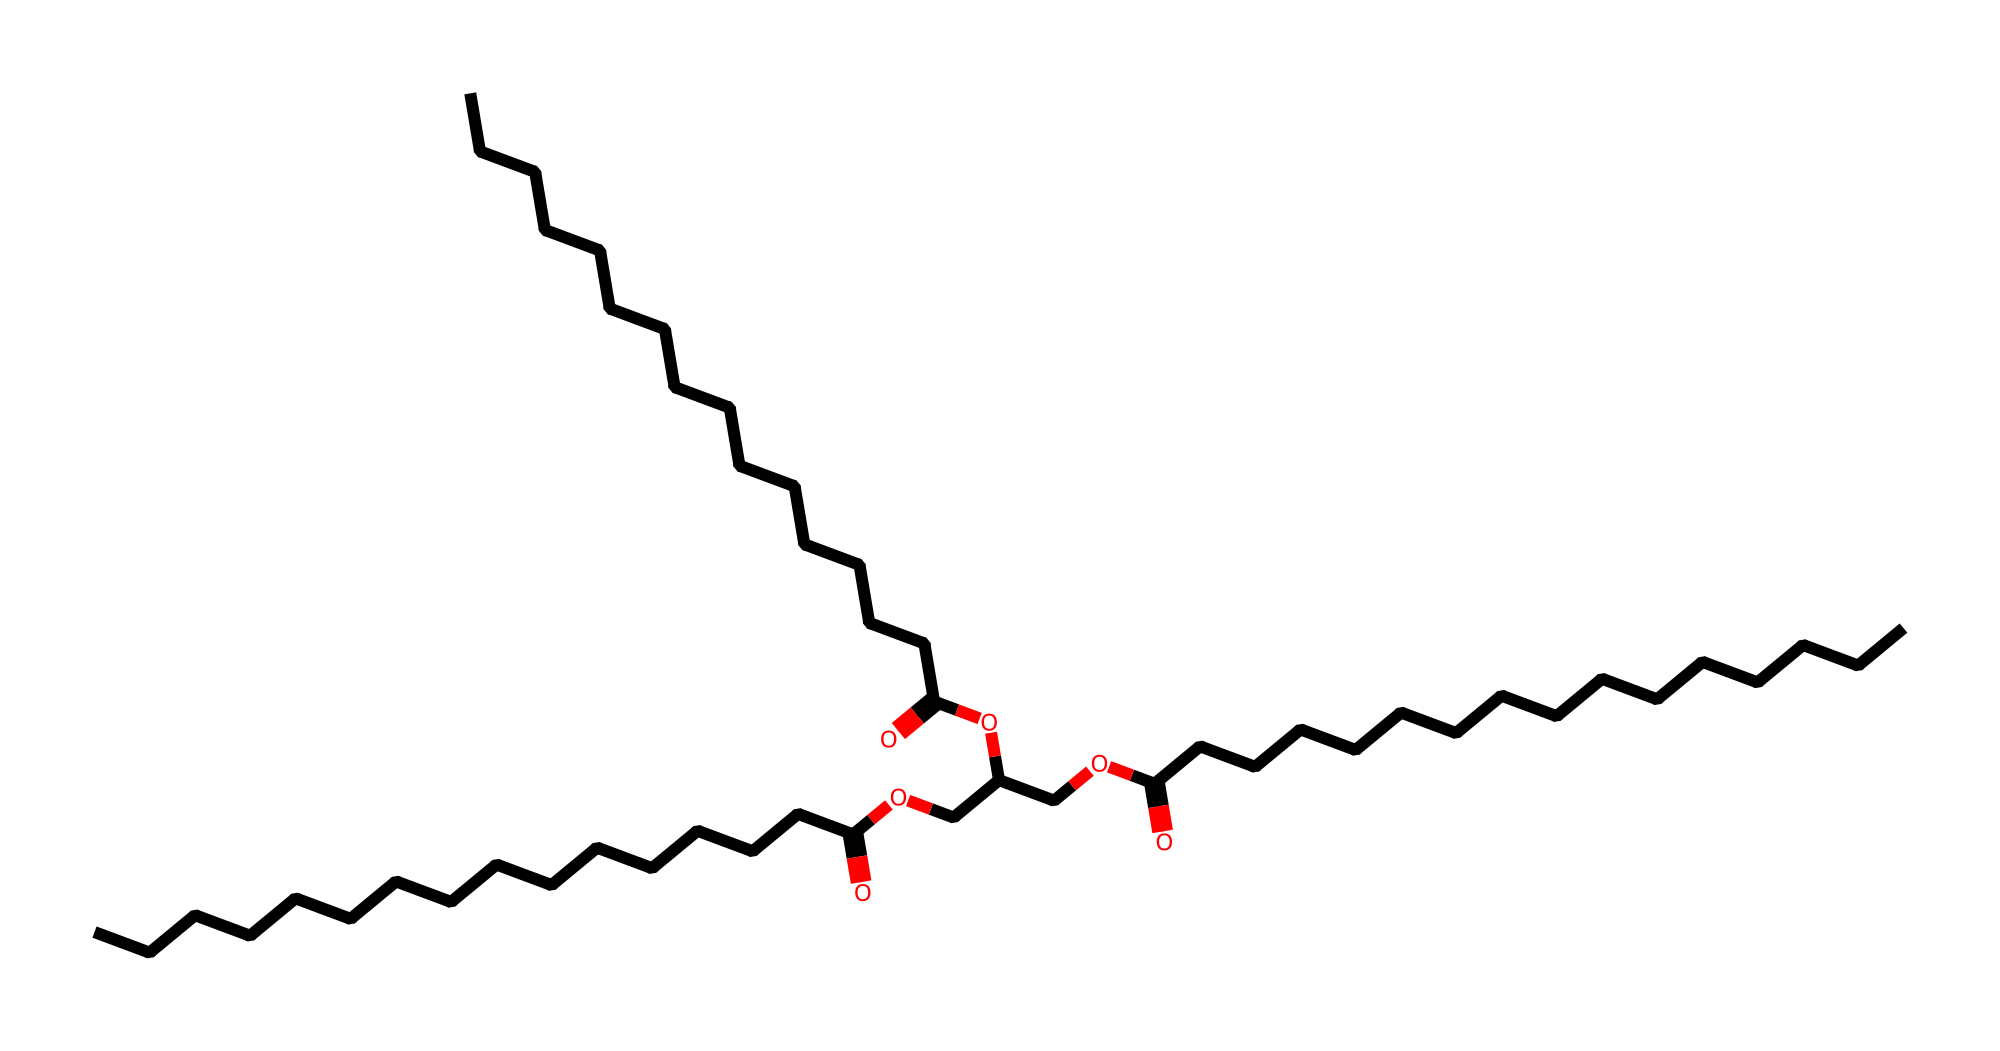How many carbon atoms are in this triglyceride? To find the number of carbon atoms, count the carbon symbols (C) in the SMILES representation. Each "C" represents one carbon atom. The structure reveals a total of 51 carbon atoms.
Answer: 51 What is the role of the ester functional groups in this molecule? Ester functional groups are formed through the reaction between alcohols and carboxylic acids, allowing triglycerides to store energy efficiently. The presence of these groups indicates that this molecule can serve as an energy-dense nutrient.
Answer: energy storage How many double bonds are present in this triglyceride? Examine the SMILES representation for any portions that indicate double bonds, which would be symbolized as "=". In this chemical, there are no double bonds present, indicating it is a saturated triglyceride.
Answer: 0 What type of lipid is indicated by this structure? The presence of a glycerol backbone attached to three fatty acid chains categorizes this chemical as a triglyceride. This type of lipid is primarily used for energy storage in organisms.
Answer: triglyceride Why is this triglyceride considered energy-dense? The large number of carbon and hydrogen atoms in the fatty acid chains provides extensive energy when metabolized. The structure showcases long hydrocarbon chains that can yield high amounts of energy during breakdown.
Answer: extensive energy How does this triglyceride contribute to endurance training? The triglyceride serves as a concentrated energy source that can be metabolized during long-duration physical activity. Its fatty acid chains release energy gradually, supporting sustained performance.
Answer: sustained energy 